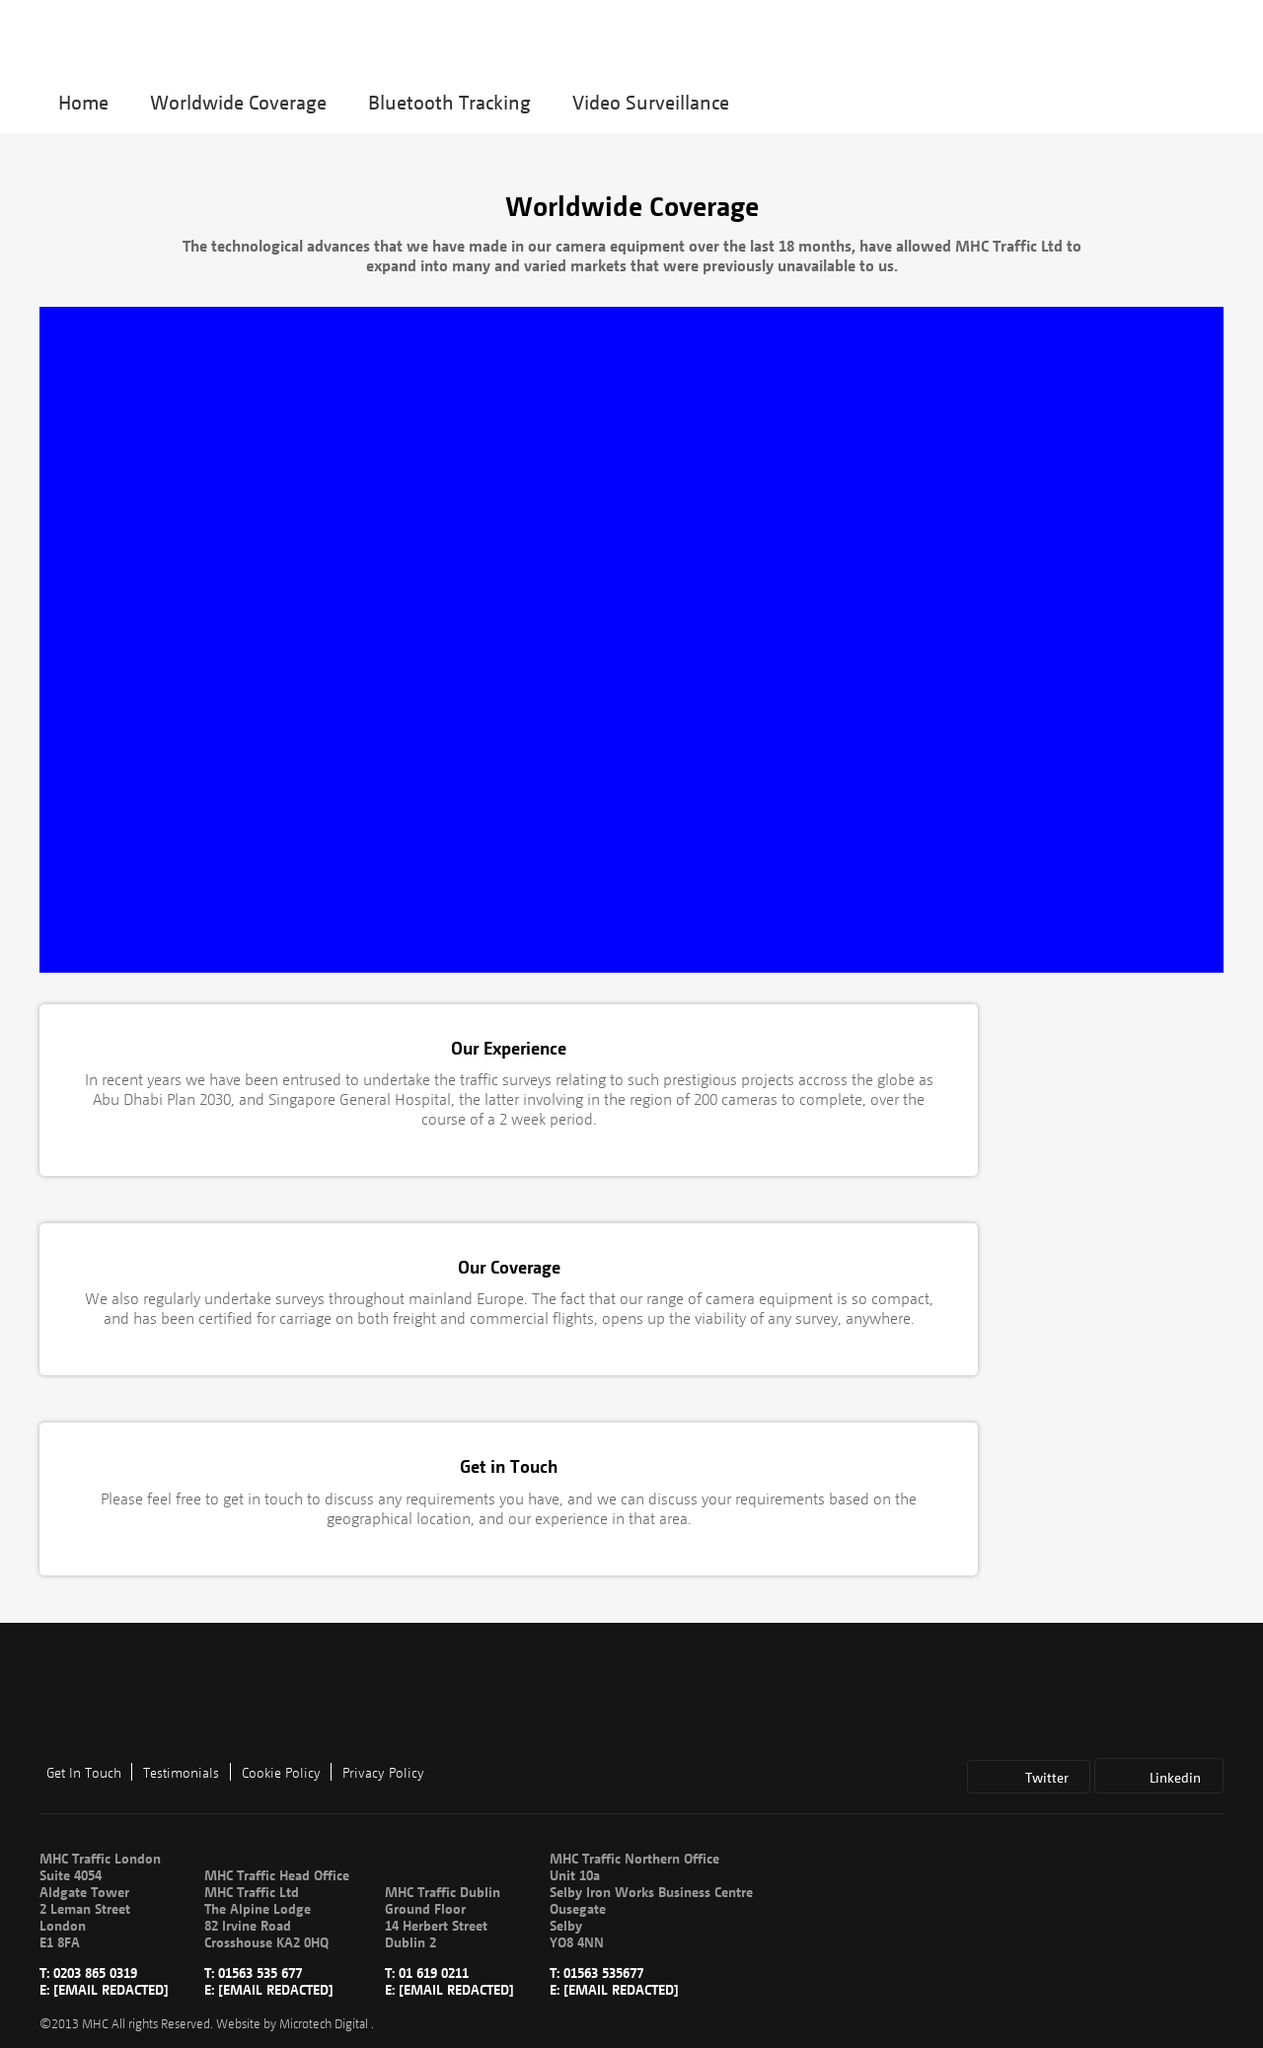What are some important considerations when designing a website for worldwide coverage? When designing a website for worldwide coverage, it's essential to consider multilingual support to cater to different regions, ensure the website loads efficiently globally by optimizing images and using CDN services, and be aware of cultural sensitivities to tailor content appropriately. Additionally, ensuring compliance with international data protection regulations, like GDPR, is crucial. 